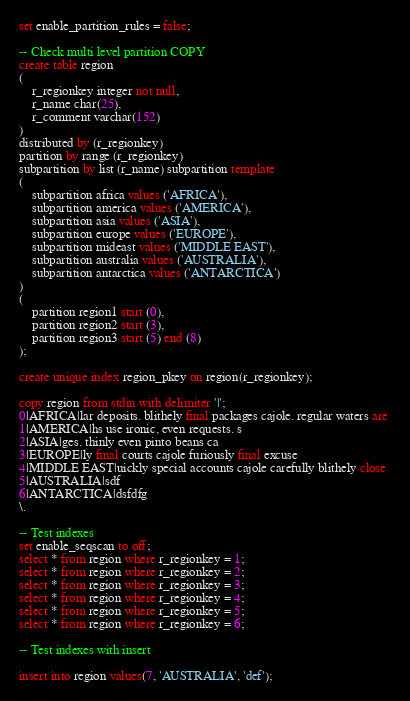Convert code to text. <code><loc_0><loc_0><loc_500><loc_500><_SQL_>set enable_partition_rules = false;

-- Check multi level partition COPY
create table region
(
	r_regionkey integer not null,
	r_name char(25),
	r_comment varchar(152)
)
distributed by (r_regionkey)
partition by range (r_regionkey)
subpartition by list (r_name) subpartition template
(
	subpartition africa values ('AFRICA'),
	subpartition america values ('AMERICA'),
	subpartition asia values ('ASIA'),
	subpartition europe values ('EUROPE'),
	subpartition mideast values ('MIDDLE EAST'),
	subpartition australia values ('AUSTRALIA'),
	subpartition antarctica values ('ANTARCTICA')
)
(
	partition region1 start (0),
	partition region2 start (3),
	partition region3 start (5) end (8)
);

create unique index region_pkey on region(r_regionkey);

copy region from stdin with delimiter '|';
0|AFRICA|lar deposits. blithely final packages cajole. regular waters are 
1|AMERICA|hs use ironic, even requests. s
2|ASIA|ges. thinly even pinto beans ca
3|EUROPE|ly final courts cajole furiously final excuse
4|MIDDLE EAST|uickly special accounts cajole carefully blithely close 
5|AUSTRALIA|sdf
6|ANTARCTICA|dsfdfg
\.

-- Test indexes
set enable_seqscan to off;
select * from region where r_regionkey = 1;
select * from region where r_regionkey = 2;
select * from region where r_regionkey = 3;
select * from region where r_regionkey = 4;
select * from region where r_regionkey = 5;
select * from region where r_regionkey = 6;

-- Test indexes with insert

insert into region values(7, 'AUSTRALIA', 'def');</code> 